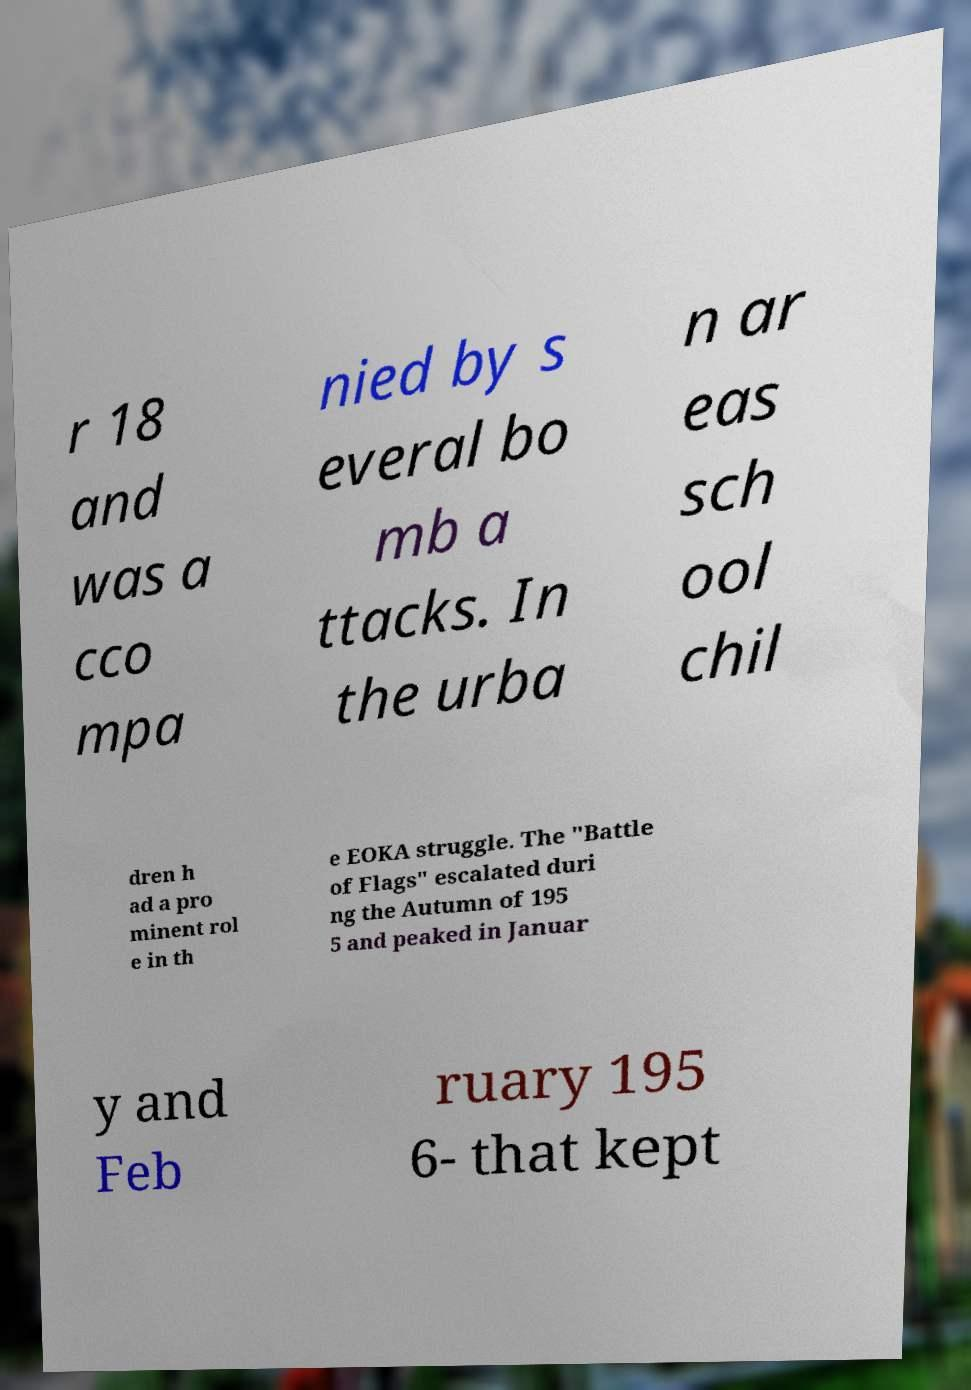Can you accurately transcribe the text from the provided image for me? r 18 and was a cco mpa nied by s everal bo mb a ttacks. In the urba n ar eas sch ool chil dren h ad a pro minent rol e in th e EOKA struggle. The "Battle of Flags" escalated duri ng the Autumn of 195 5 and peaked in Januar y and Feb ruary 195 6- that kept 